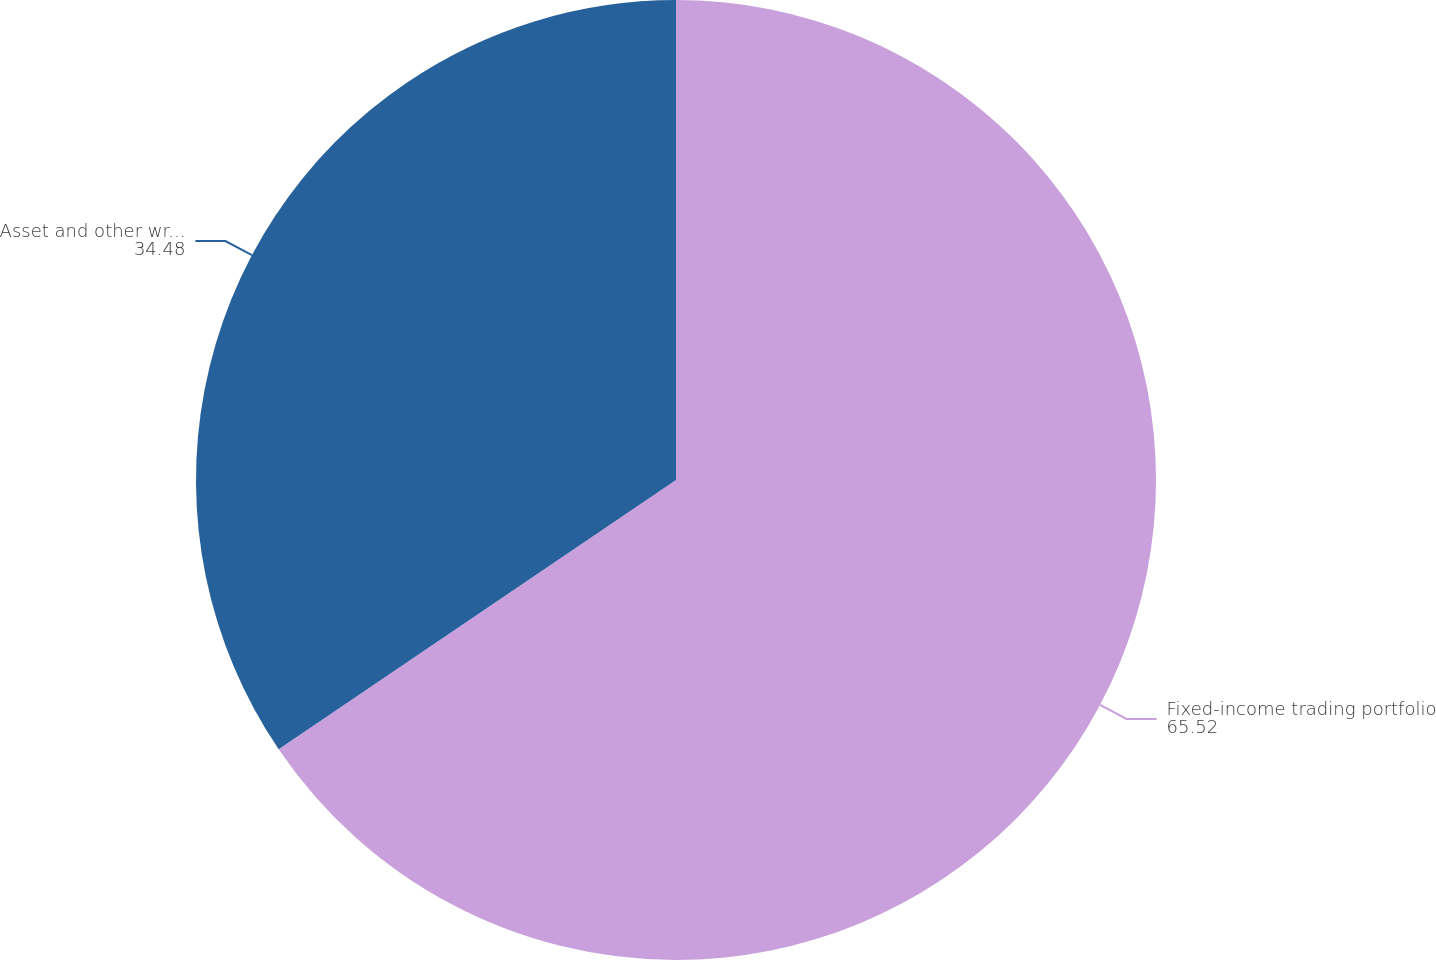<chart> <loc_0><loc_0><loc_500><loc_500><pie_chart><fcel>Fixed-income trading portfolio<fcel>Asset and other write-offs<nl><fcel>65.52%<fcel>34.48%<nl></chart> 